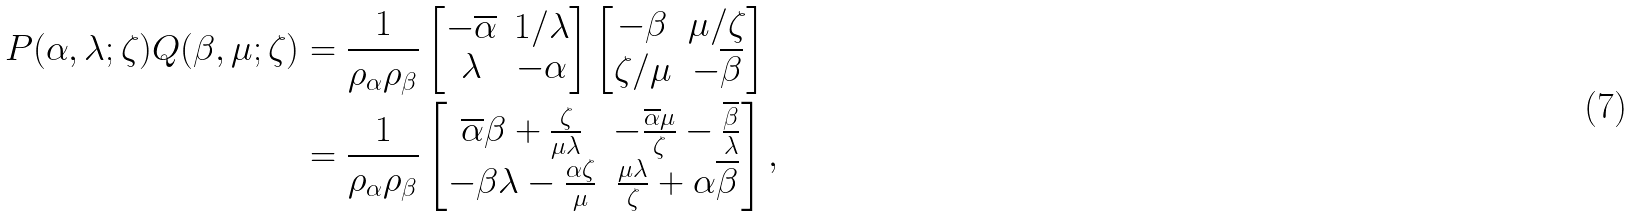<formula> <loc_0><loc_0><loc_500><loc_500>P ( \alpha , \lambda ; \zeta ) Q ( \beta , \mu ; \zeta ) & = \frac { 1 } { \rho _ { \alpha } \rho _ { \beta } } \begin{bmatrix} - \overline { \alpha } & 1 / \lambda \\ \lambda & - \alpha \end{bmatrix} \begin{bmatrix} - \beta & \mu / \zeta \\ \zeta / \mu & - \overline { \beta } \end{bmatrix} \\ & = \frac { 1 } { \rho _ { \alpha } \rho _ { \beta } } \begin{bmatrix} \overline { \alpha } \beta + \frac { \zeta } { \mu \lambda } & - \frac { \overline { \alpha } \mu } { \zeta } - \frac { \overline { \beta } } { \lambda } \\ - \beta \lambda - \frac { \alpha \zeta } { \mu } & \frac { \mu \lambda } { \zeta } + \alpha \overline { \beta } \end{bmatrix} ,</formula> 